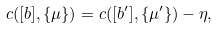<formula> <loc_0><loc_0><loc_500><loc_500>c ( [ b ] , \{ \mu \} ) = c ( [ b ^ { \prime } ] , \{ \mu ^ { \prime } \} ) - \eta ,</formula> 